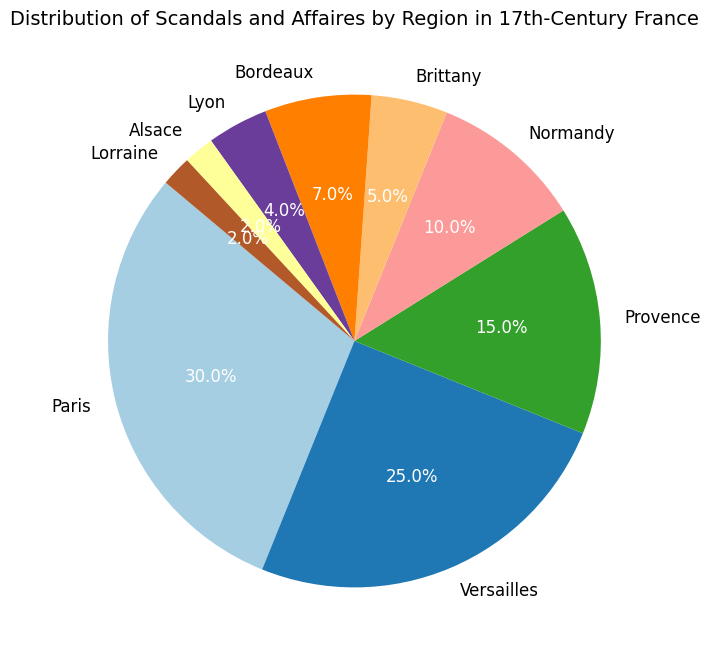Which region has the highest percentage of scandals and affaires? The region with the highest percentage is represented by the largest section of the pie chart.
Answer: Paris What is the total percentage of scandals and affaires in Normandy and Brittany combined? Add the percentages of Normandy and Brittany: 10% + 5% = 15%.
Answer: 15% Which two regions have the smallest percentage of scandals and affaires? The smallest sections of the pie chart correspond to the regions with 2% each.
Answer: Alsace and Lorraine Is the percentage of scandals and affaires in Versailles greater than that in Normandy and Brittany combined? Compare Versailles' 25% to the combined 15% of Normandy and Brittany: 25% > 15%.
Answer: Yes What is the difference in the percentage of scandals and affaires between Paris and Lyon? Subtract Lyon's percentage from Paris's: 30% - 4% = 26%.
Answer: 26% Which regions have a percentage of scandals and affaires greater than 20%? Identify sections with more than 20%: Paris and Versailles.
Answer: Paris and Versailles By how much does Provence exceed Bordeaux in percentage of scandals and affaires? Subtract Bordeaux's percentage from Provence's: 15% - 7% = 8%.
Answer: 8% What is the total percentage of scandals and affaires for regions besides Paris, Versailles, and Provence? Sum up all other regions: 10% (Normandy) + 5% (Brittany) + 7% (Bordeaux) + 4% (Lyon) + 2% (Alsace) + 2% (Lorraine) = 30%.
Answer: 30% Which regions have percentages represented in shades of blue in the pie chart? Since the exact shades are not specified, this would need to be inferred visually.
Answer: Information not provided 